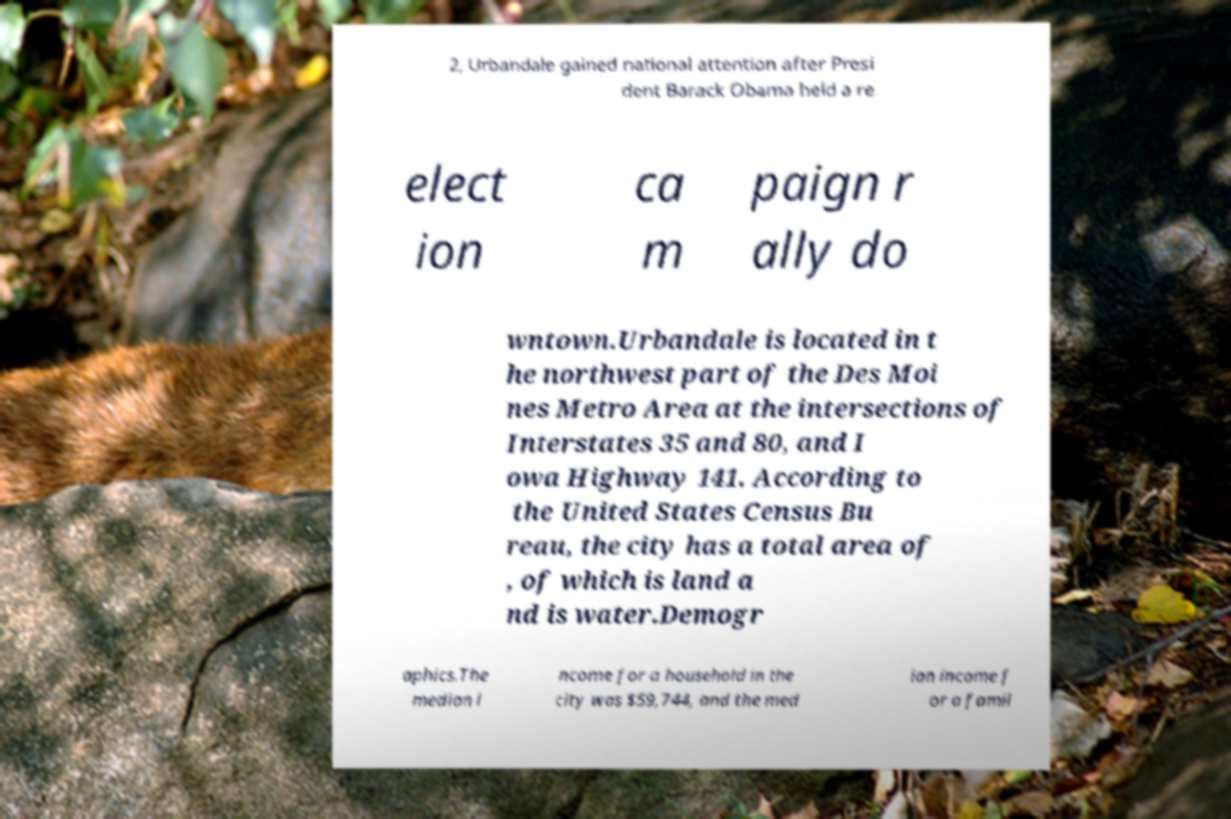Please read and relay the text visible in this image. What does it say? 2, Urbandale gained national attention after Presi dent Barack Obama held a re elect ion ca m paign r ally do wntown.Urbandale is located in t he northwest part of the Des Moi nes Metro Area at the intersections of Interstates 35 and 80, and I owa Highway 141. According to the United States Census Bu reau, the city has a total area of , of which is land a nd is water.Demogr aphics.The median i ncome for a household in the city was $59,744, and the med ian income f or a famil 